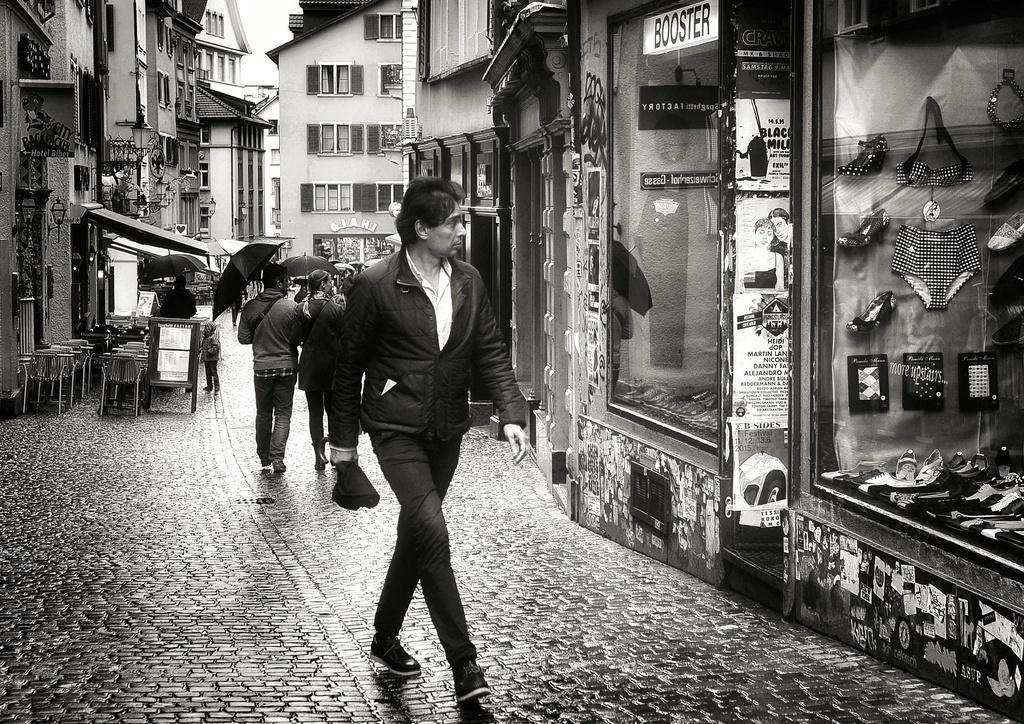Could you give a brief overview of what you see in this image? In the foreground we can see a man walking on the road. He is wearing a black color jacket and he is holding an umbrella in his right hand. Here we can see the glass windows on the right side. Here we can see the clothes and the footwear on the right side. In the background, we can see two people walking on the road and they are holding the umbrellas. Here we can see the chairs on the left side. In the background, we can see the buildings. 